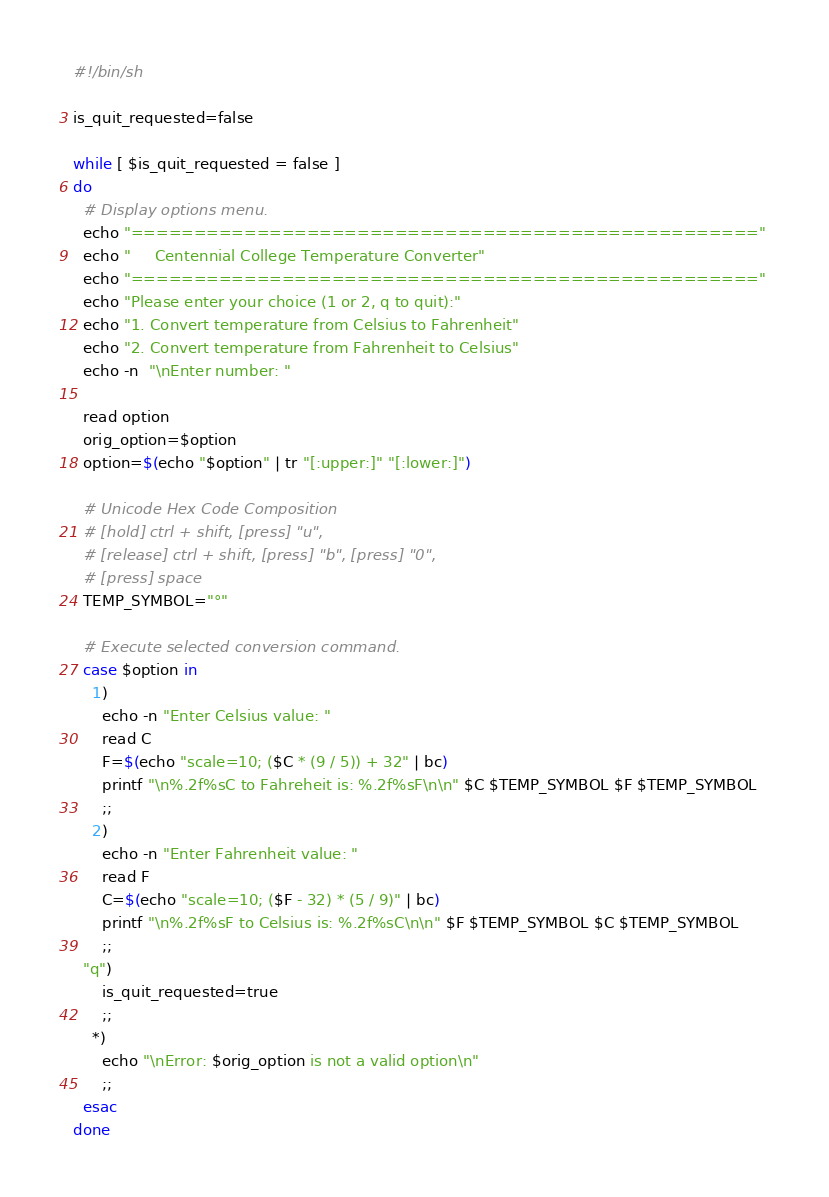Convert code to text. <code><loc_0><loc_0><loc_500><loc_500><_Bash_>#!/bin/sh

is_quit_requested=false

while [ $is_quit_requested = false ]
do
  # Display options menu.
  echo "=================================================="
  echo "     Centennial College Temperature Converter"
  echo "=================================================="
  echo "Please enter your choice (1 or 2, q to quit):"
  echo "1. Convert temperature from Celsius to Fahrenheit"
  echo "2. Convert temperature from Fahrenheit to Celsius" 
  echo -n  "\nEnter number: "

  read option
  orig_option=$option
  option=$(echo "$option" | tr "[:upper:]" "[:lower:]") 

  # Unicode Hex Code Composition
  # [hold] ctrl + shift, [press] "u",
  # [release] ctrl + shift, [press] "b", [press] "0",
  # [press] space
  TEMP_SYMBOL="°"

  # Execute selected conversion command.  
  case $option in
    1)
      echo -n "Enter Celsius value: "
      read C
      F=$(echo "scale=10; ($C * (9 / 5)) + 32" | bc)
      printf "\n%.2f%sC to Fahreheit is: %.2f%sF\n\n" $C $TEMP_SYMBOL $F $TEMP_SYMBOL   
      ;;
    2)
      echo -n "Enter Fahrenheit value: "
      read F  
      C=$(echo "scale=10; ($F - 32) * (5 / 9)" | bc)
      printf "\n%.2f%sF to Celsius is: %.2f%sC\n\n" $F $TEMP_SYMBOL $C $TEMP_SYMBOL  
      ;;
  "q")
      is_quit_requested=true
      ;;
    *)
      echo "\nError: $orig_option is not a valid option\n"
      ;; 
  esac 
done
</code> 